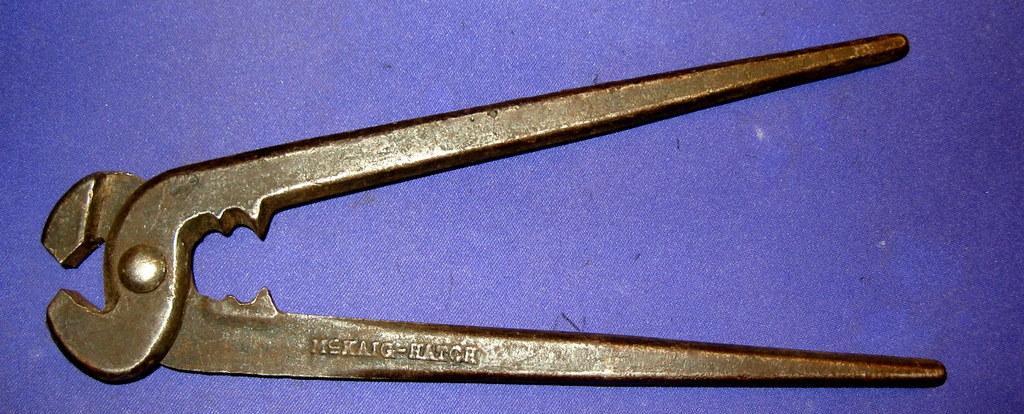How would you summarize this image in a sentence or two? In this picture we can see a tool on a violet surface. 